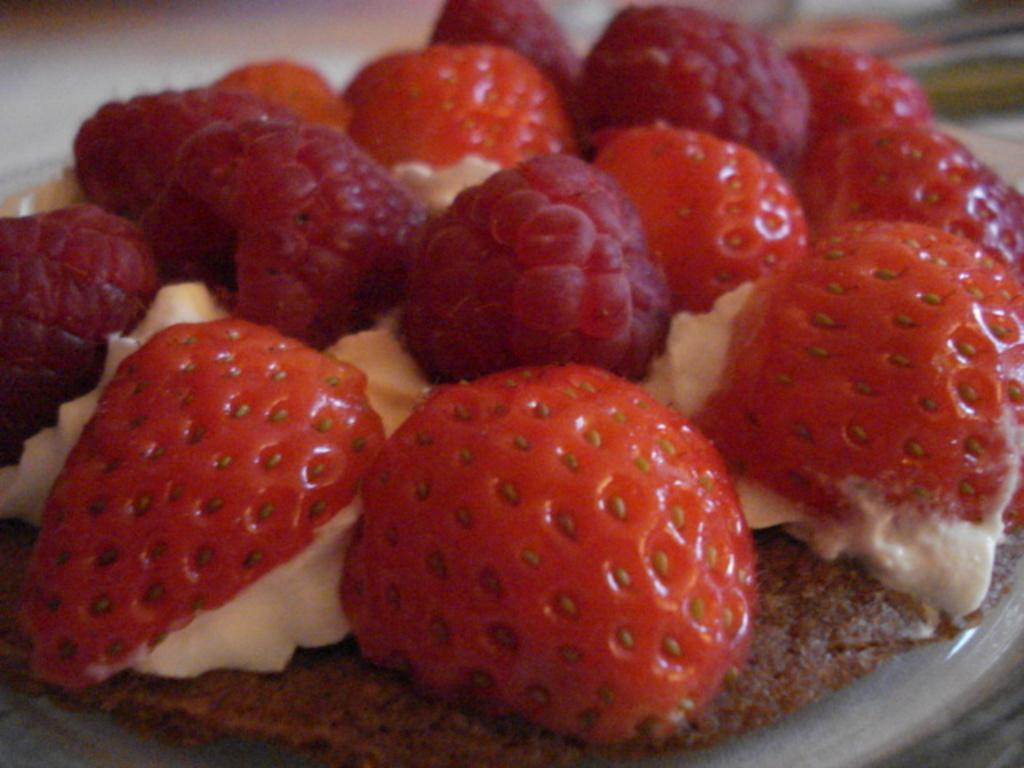What type of fruit is present in the image? There are strawberries in the image. What type of chain can be seen connecting the strawberries in the image? There is no chain present in the image; it only features strawberries. What part of the brain can be seen in the image? There is no brain present in the image; it only features strawberries. 